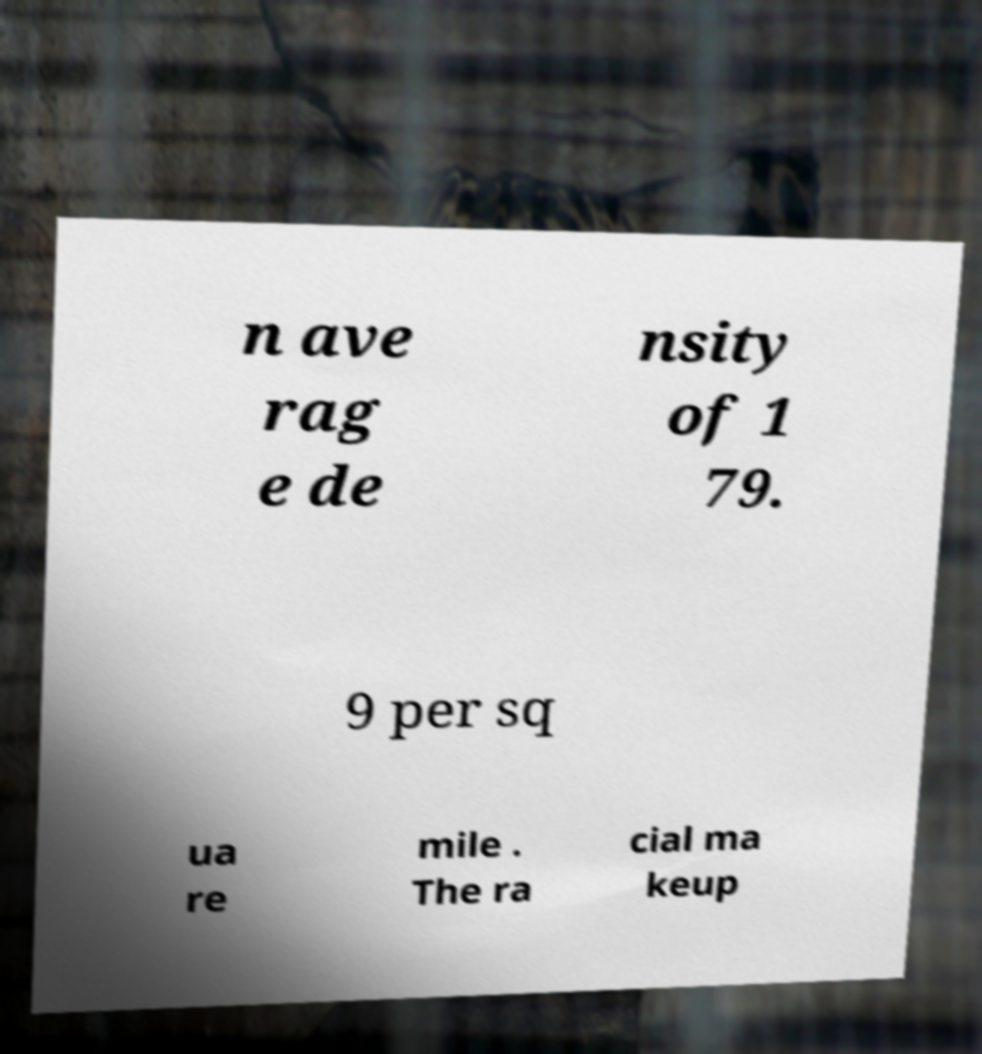For documentation purposes, I need the text within this image transcribed. Could you provide that? n ave rag e de nsity of 1 79. 9 per sq ua re mile . The ra cial ma keup 